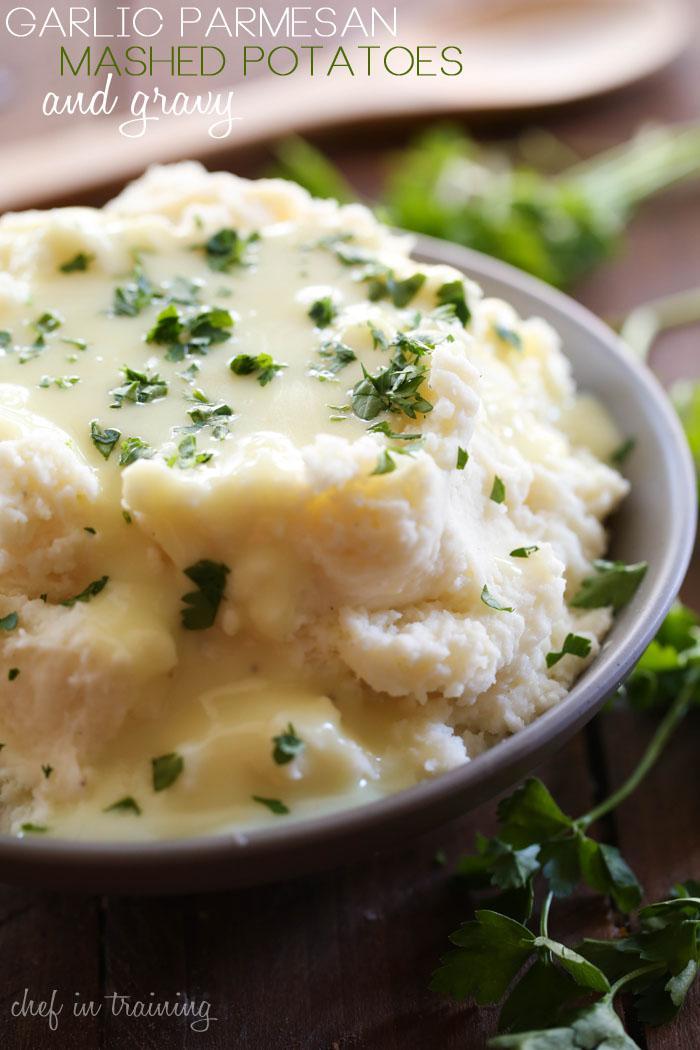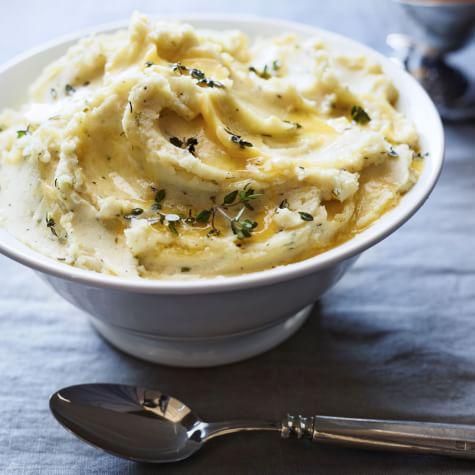The first image is the image on the left, the second image is the image on the right. Considering the images on both sides, is "One image shows two servings of mashed potatoes in purple bowls." valid? Answer yes or no. No. The first image is the image on the left, the second image is the image on the right. Given the left and right images, does the statement "There are two bowls of potatoes in one of the images." hold true? Answer yes or no. No. 